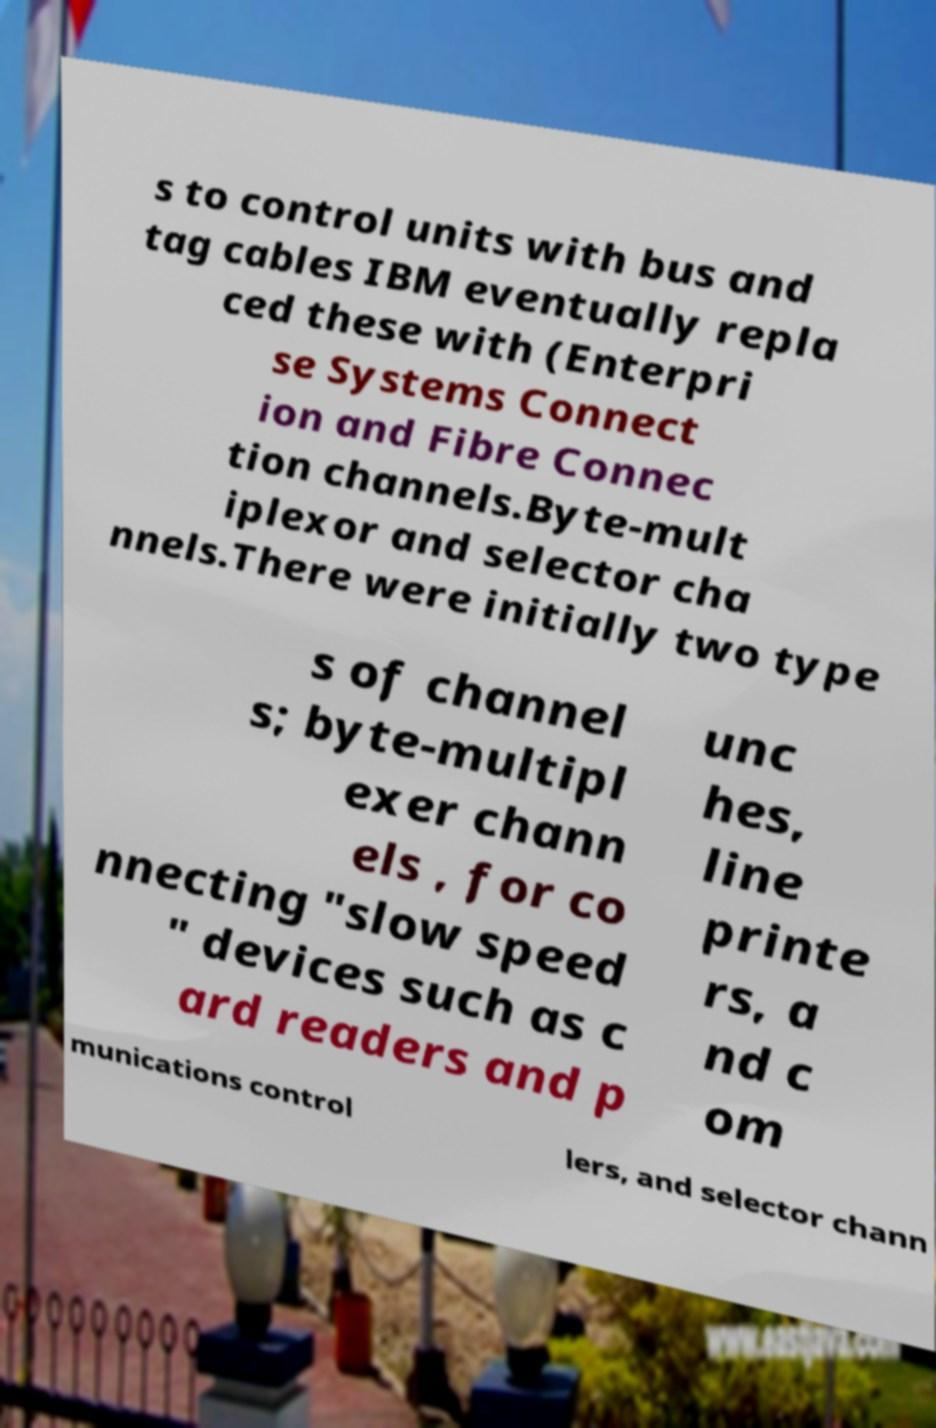For documentation purposes, I need the text within this image transcribed. Could you provide that? s to control units with bus and tag cables IBM eventually repla ced these with (Enterpri se Systems Connect ion and Fibre Connec tion channels.Byte-mult iplexor and selector cha nnels.There were initially two type s of channel s; byte-multipl exer chann els , for co nnecting "slow speed " devices such as c ard readers and p unc hes, line printe rs, a nd c om munications control lers, and selector chann 